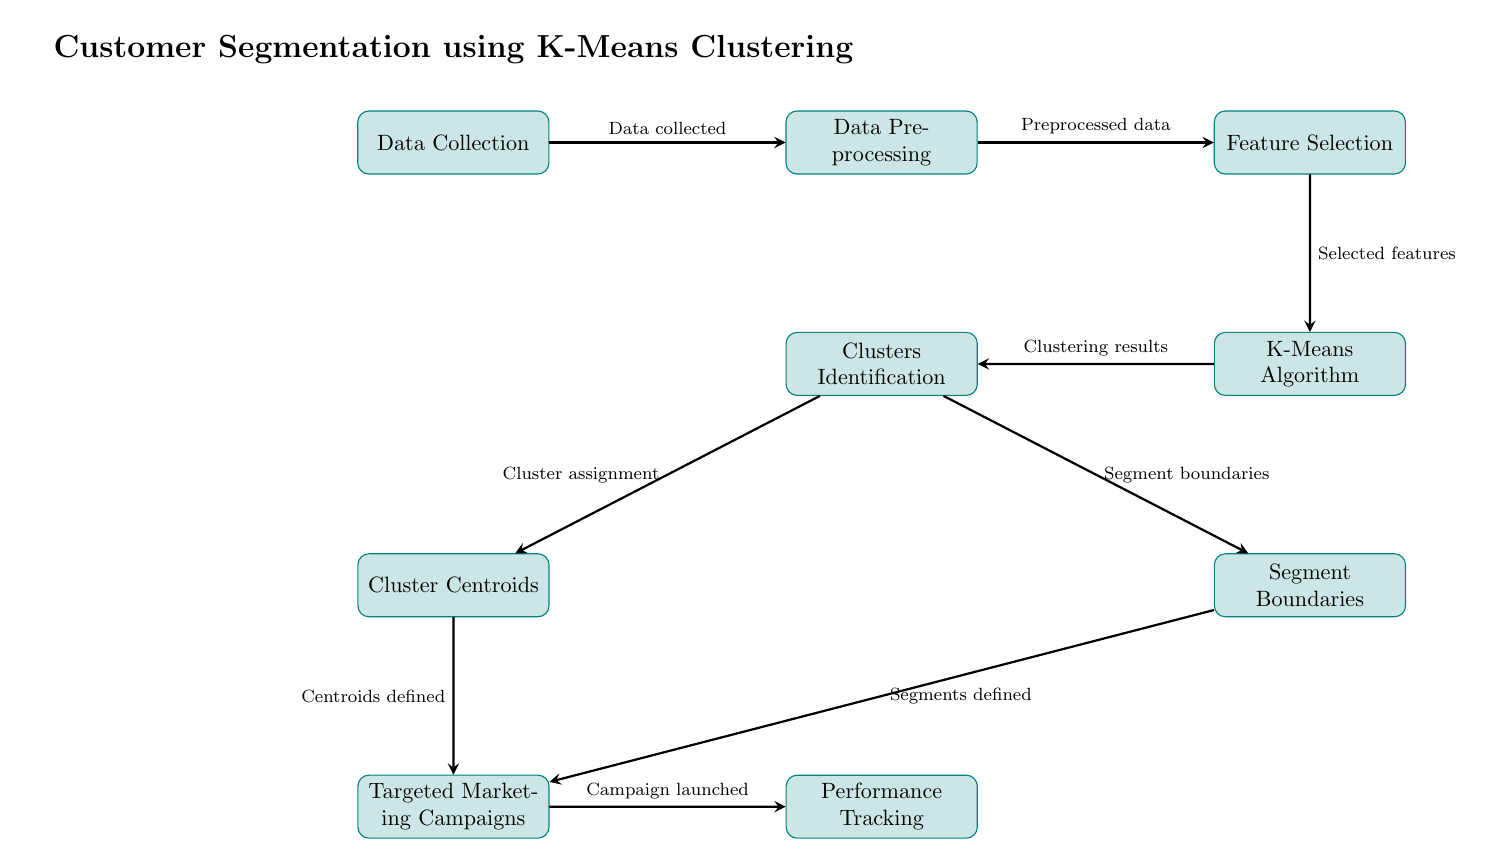What is the first step in the process? The first step is "Data Collection", which is indicated as the topmost node in the diagram.
Answer: Data Collection How many processes are depicted in the diagram? By counting the rectangular nodes representing processes in the diagram, there are a total of eight processes illustrated.
Answer: Eight Which node comes after "Feature Selection"? The node following "Feature Selection" is "K-Means Algorithm", as shown by the arrow connecting them.
Answer: K-Means Algorithm What do the arrows represent in this diagram? The arrows indicate the flow of the process, showing the sequence and relationship of each step from start to finish.
Answer: Flow of the process What is the output from the "K-Means Algorithm"? The output is "Clustering results", which is the label in the node immediately below "K-Means Algorithm".
Answer: Clustering results Which two nodes lead to "Targeted Marketing Campaigns"? The two nodes are "Cluster Centroids" and "Segment Boundaries", both of which have arrows pointing to "Targeted Marketing Campaigns".
Answer: Cluster Centroids and Segment Boundaries What is defined in the "Cluster Centroids" node? "Centroids defined" is indicated as the output or definition resulting from the "Cluster Centroids" process within the diagram.
Answer: Centroids defined What connection exists between "Clusters Identification" and "Segment Boundaries"? "Clusters Identification" has an arrow pointing to "Segment Boundaries", indicating that clusters lead to defining segment boundaries.
Answer: Arrow pointing to Segment Boundaries Which step follows the "Performance Tracking"? The diagram does not indicate any further steps following "Performance Tracking", making it the final step in the process.
Answer: None 